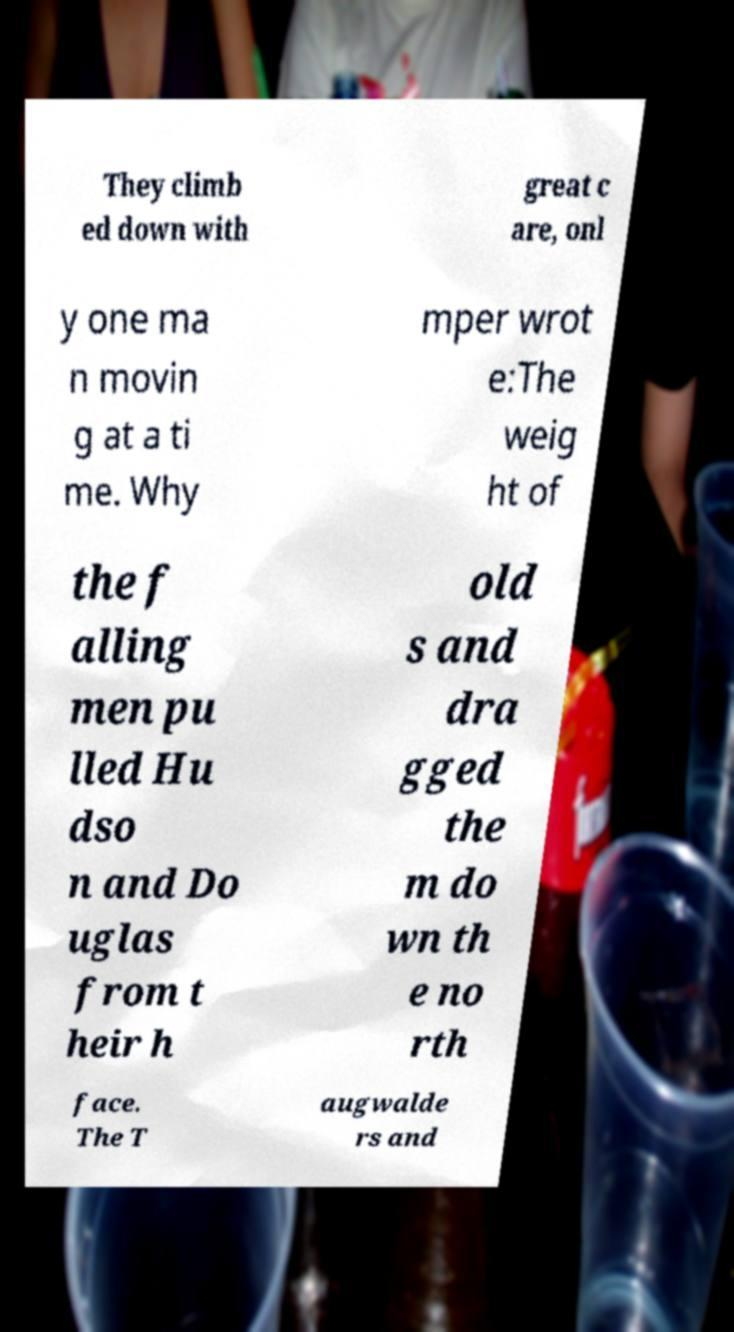For documentation purposes, I need the text within this image transcribed. Could you provide that? They climb ed down with great c are, onl y one ma n movin g at a ti me. Why mper wrot e:The weig ht of the f alling men pu lled Hu dso n and Do uglas from t heir h old s and dra gged the m do wn th e no rth face. The T augwalde rs and 